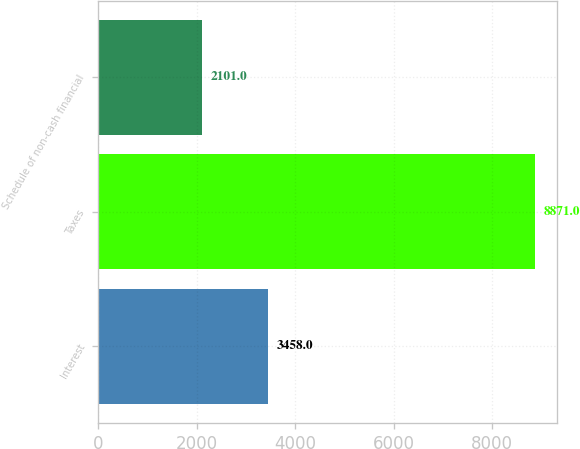Convert chart. <chart><loc_0><loc_0><loc_500><loc_500><bar_chart><fcel>Interest<fcel>Taxes<fcel>Schedule of non-cash financial<nl><fcel>3458<fcel>8871<fcel>2101<nl></chart> 